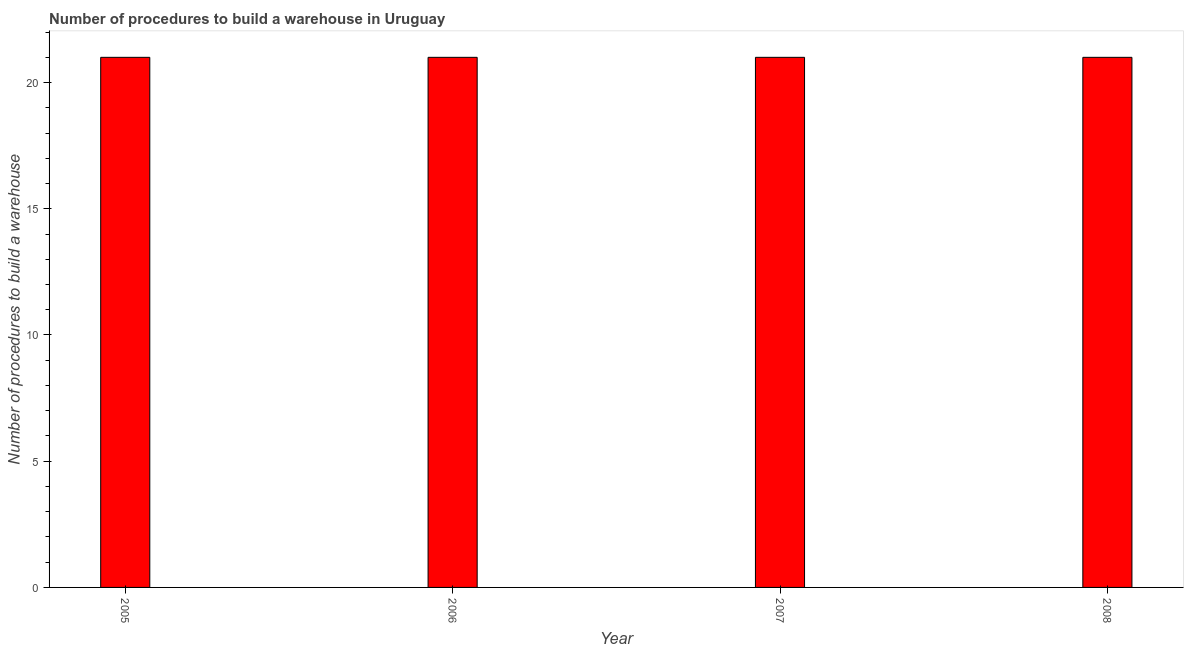Does the graph contain grids?
Your response must be concise. No. What is the title of the graph?
Ensure brevity in your answer.  Number of procedures to build a warehouse in Uruguay. What is the label or title of the X-axis?
Provide a succinct answer. Year. What is the label or title of the Y-axis?
Your response must be concise. Number of procedures to build a warehouse. Across all years, what is the maximum number of procedures to build a warehouse?
Give a very brief answer. 21. Across all years, what is the minimum number of procedures to build a warehouse?
Provide a succinct answer. 21. In which year was the number of procedures to build a warehouse minimum?
Offer a terse response. 2005. What is the sum of the number of procedures to build a warehouse?
Provide a succinct answer. 84. What is the difference between the number of procedures to build a warehouse in 2006 and 2007?
Give a very brief answer. 0. What is the average number of procedures to build a warehouse per year?
Offer a terse response. 21. What is the ratio of the number of procedures to build a warehouse in 2005 to that in 2006?
Provide a succinct answer. 1. Is the number of procedures to build a warehouse in 2005 less than that in 2008?
Give a very brief answer. No. Is the difference between the number of procedures to build a warehouse in 2005 and 2006 greater than the difference between any two years?
Your answer should be compact. Yes. Is the sum of the number of procedures to build a warehouse in 2005 and 2008 greater than the maximum number of procedures to build a warehouse across all years?
Offer a very short reply. Yes. In how many years, is the number of procedures to build a warehouse greater than the average number of procedures to build a warehouse taken over all years?
Offer a very short reply. 0. How many bars are there?
Your response must be concise. 4. How many years are there in the graph?
Offer a terse response. 4. What is the difference between two consecutive major ticks on the Y-axis?
Ensure brevity in your answer.  5. Are the values on the major ticks of Y-axis written in scientific E-notation?
Keep it short and to the point. No. What is the Number of procedures to build a warehouse in 2005?
Offer a very short reply. 21. What is the Number of procedures to build a warehouse of 2008?
Provide a short and direct response. 21. What is the difference between the Number of procedures to build a warehouse in 2005 and 2006?
Make the answer very short. 0. What is the difference between the Number of procedures to build a warehouse in 2006 and 2007?
Offer a very short reply. 0. What is the difference between the Number of procedures to build a warehouse in 2007 and 2008?
Make the answer very short. 0. What is the ratio of the Number of procedures to build a warehouse in 2005 to that in 2006?
Your answer should be compact. 1. What is the ratio of the Number of procedures to build a warehouse in 2005 to that in 2007?
Keep it short and to the point. 1. What is the ratio of the Number of procedures to build a warehouse in 2005 to that in 2008?
Provide a succinct answer. 1. What is the ratio of the Number of procedures to build a warehouse in 2006 to that in 2007?
Provide a short and direct response. 1. 